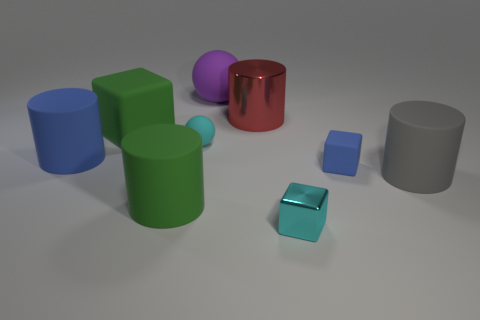Subtract all cyan blocks. How many blocks are left? 2 Subtract 1 cylinders. How many cylinders are left? 3 Subtract all blue cubes. How many cubes are left? 2 Subtract all green cubes. Subtract all green spheres. How many cubes are left? 2 Subtract all red spheres. How many yellow cubes are left? 0 Subtract all big red shiny things. Subtract all big matte objects. How many objects are left? 3 Add 4 metallic objects. How many metallic objects are left? 6 Add 7 large green cubes. How many large green cubes exist? 8 Subtract 1 cyan spheres. How many objects are left? 8 Subtract all cylinders. How many objects are left? 5 